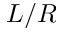<formula> <loc_0><loc_0><loc_500><loc_500>L / R</formula> 